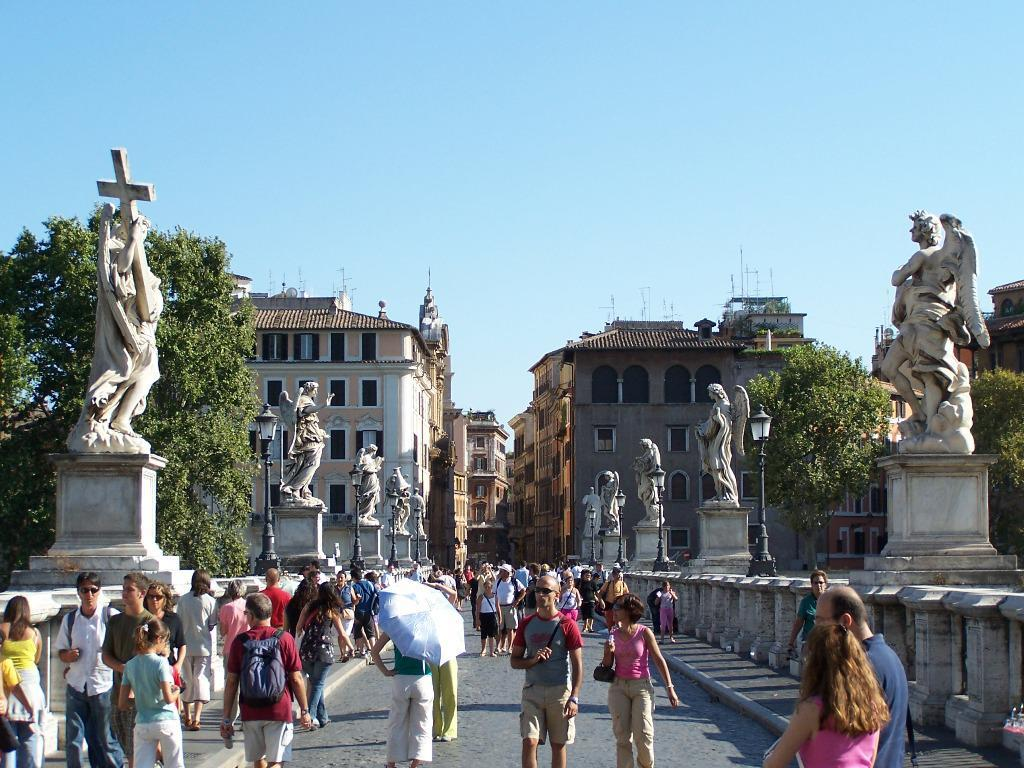What is happening on the road in the image? There are people on the road in the image. What can be seen on either side of the road? There are sculptures on either side of the image. What type of structures can be seen in the background of the image? There are buildings visible in the background of the image. What is visible at the top of the image? The sky is visible at the top of the image. How many corks are being used to hold up the sculptures in the image? There are no corks present in the image; the sculptures are not being held up by corks. What type of eggs can be seen in the image? There are no eggs present in the image. 